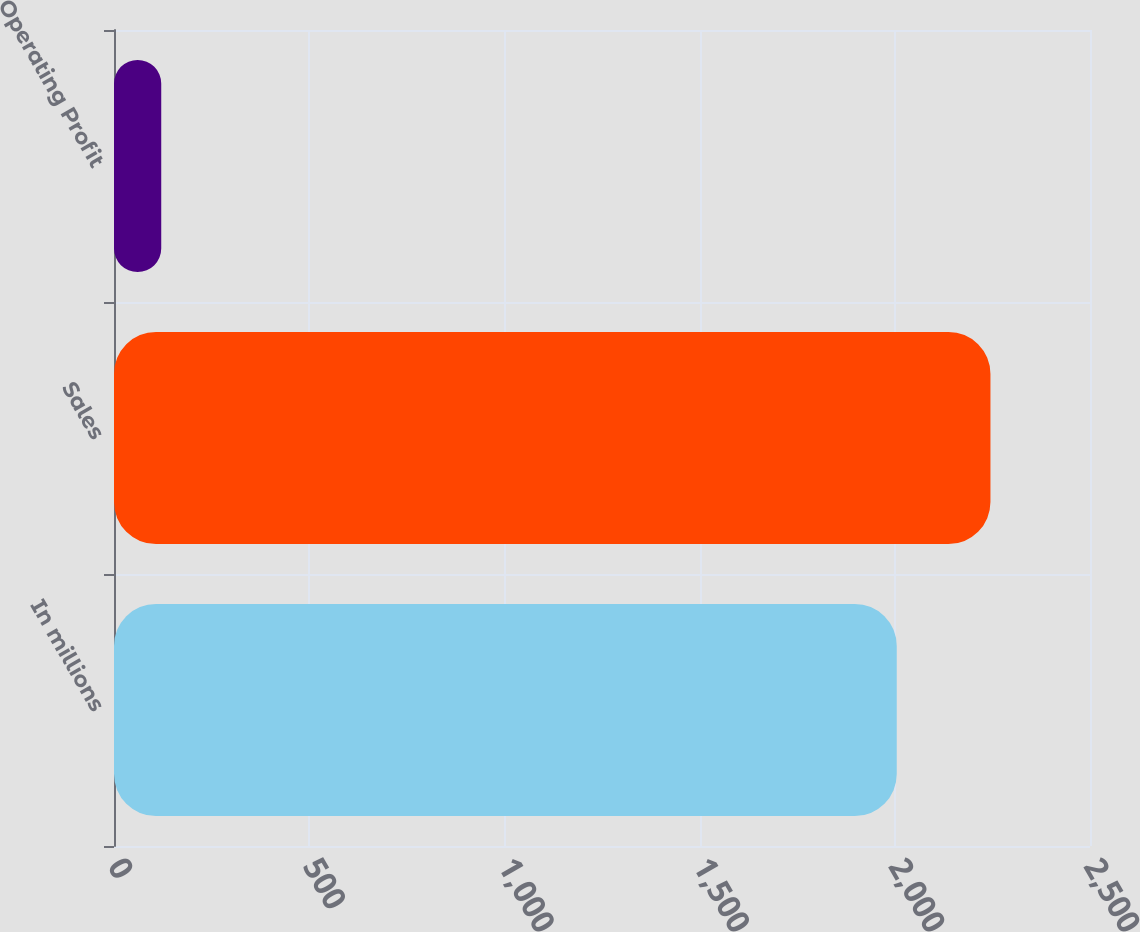Convert chart. <chart><loc_0><loc_0><loc_500><loc_500><bar_chart><fcel>In millions<fcel>Sales<fcel>Operating Profit<nl><fcel>2005<fcel>2245<fcel>121<nl></chart> 